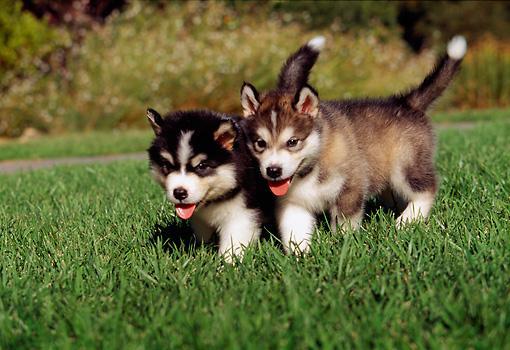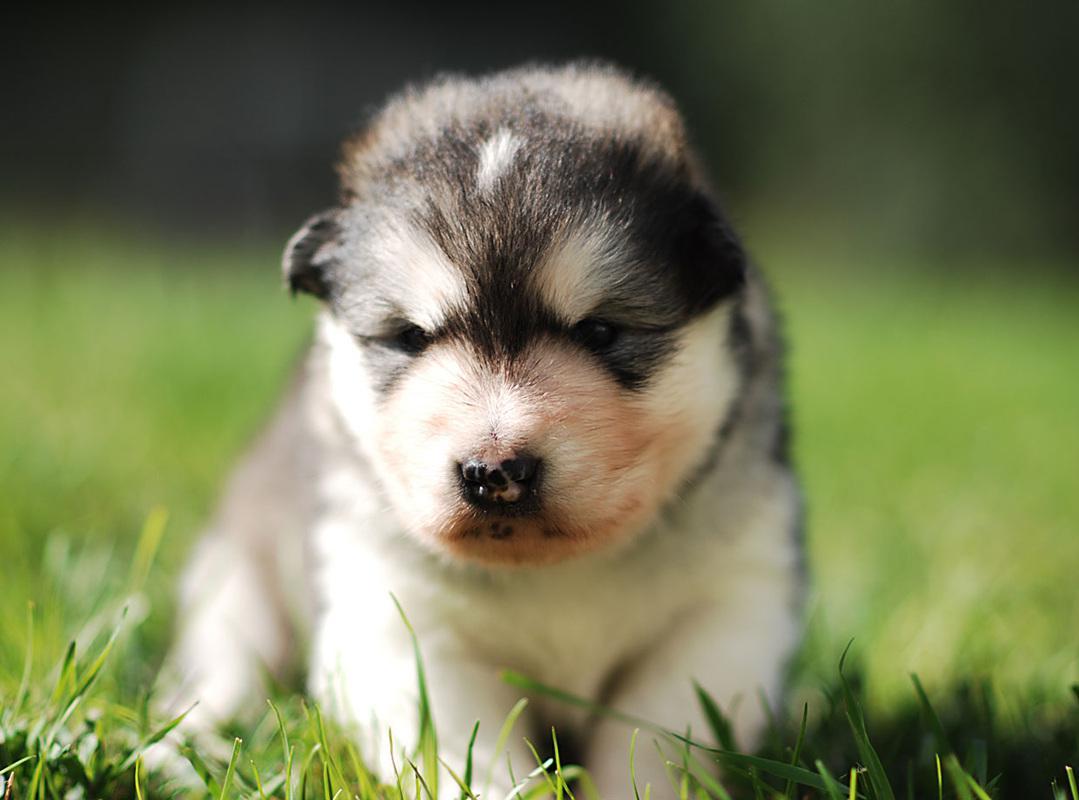The first image is the image on the left, the second image is the image on the right. Assess this claim about the two images: "There are three Husky dogs.". Correct or not? Answer yes or no. Yes. The first image is the image on the left, the second image is the image on the right. Given the left and right images, does the statement "There is a total of three dogs in both images." hold true? Answer yes or no. Yes. 